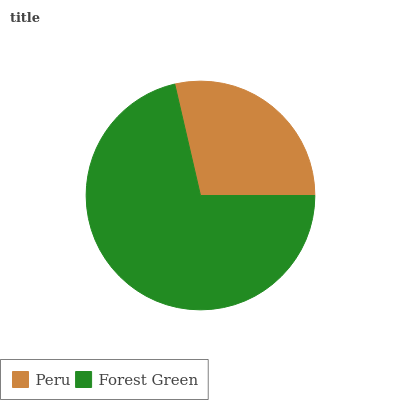Is Peru the minimum?
Answer yes or no. Yes. Is Forest Green the maximum?
Answer yes or no. Yes. Is Forest Green the minimum?
Answer yes or no. No. Is Forest Green greater than Peru?
Answer yes or no. Yes. Is Peru less than Forest Green?
Answer yes or no. Yes. Is Peru greater than Forest Green?
Answer yes or no. No. Is Forest Green less than Peru?
Answer yes or no. No. Is Forest Green the high median?
Answer yes or no. Yes. Is Peru the low median?
Answer yes or no. Yes. Is Peru the high median?
Answer yes or no. No. Is Forest Green the low median?
Answer yes or no. No. 